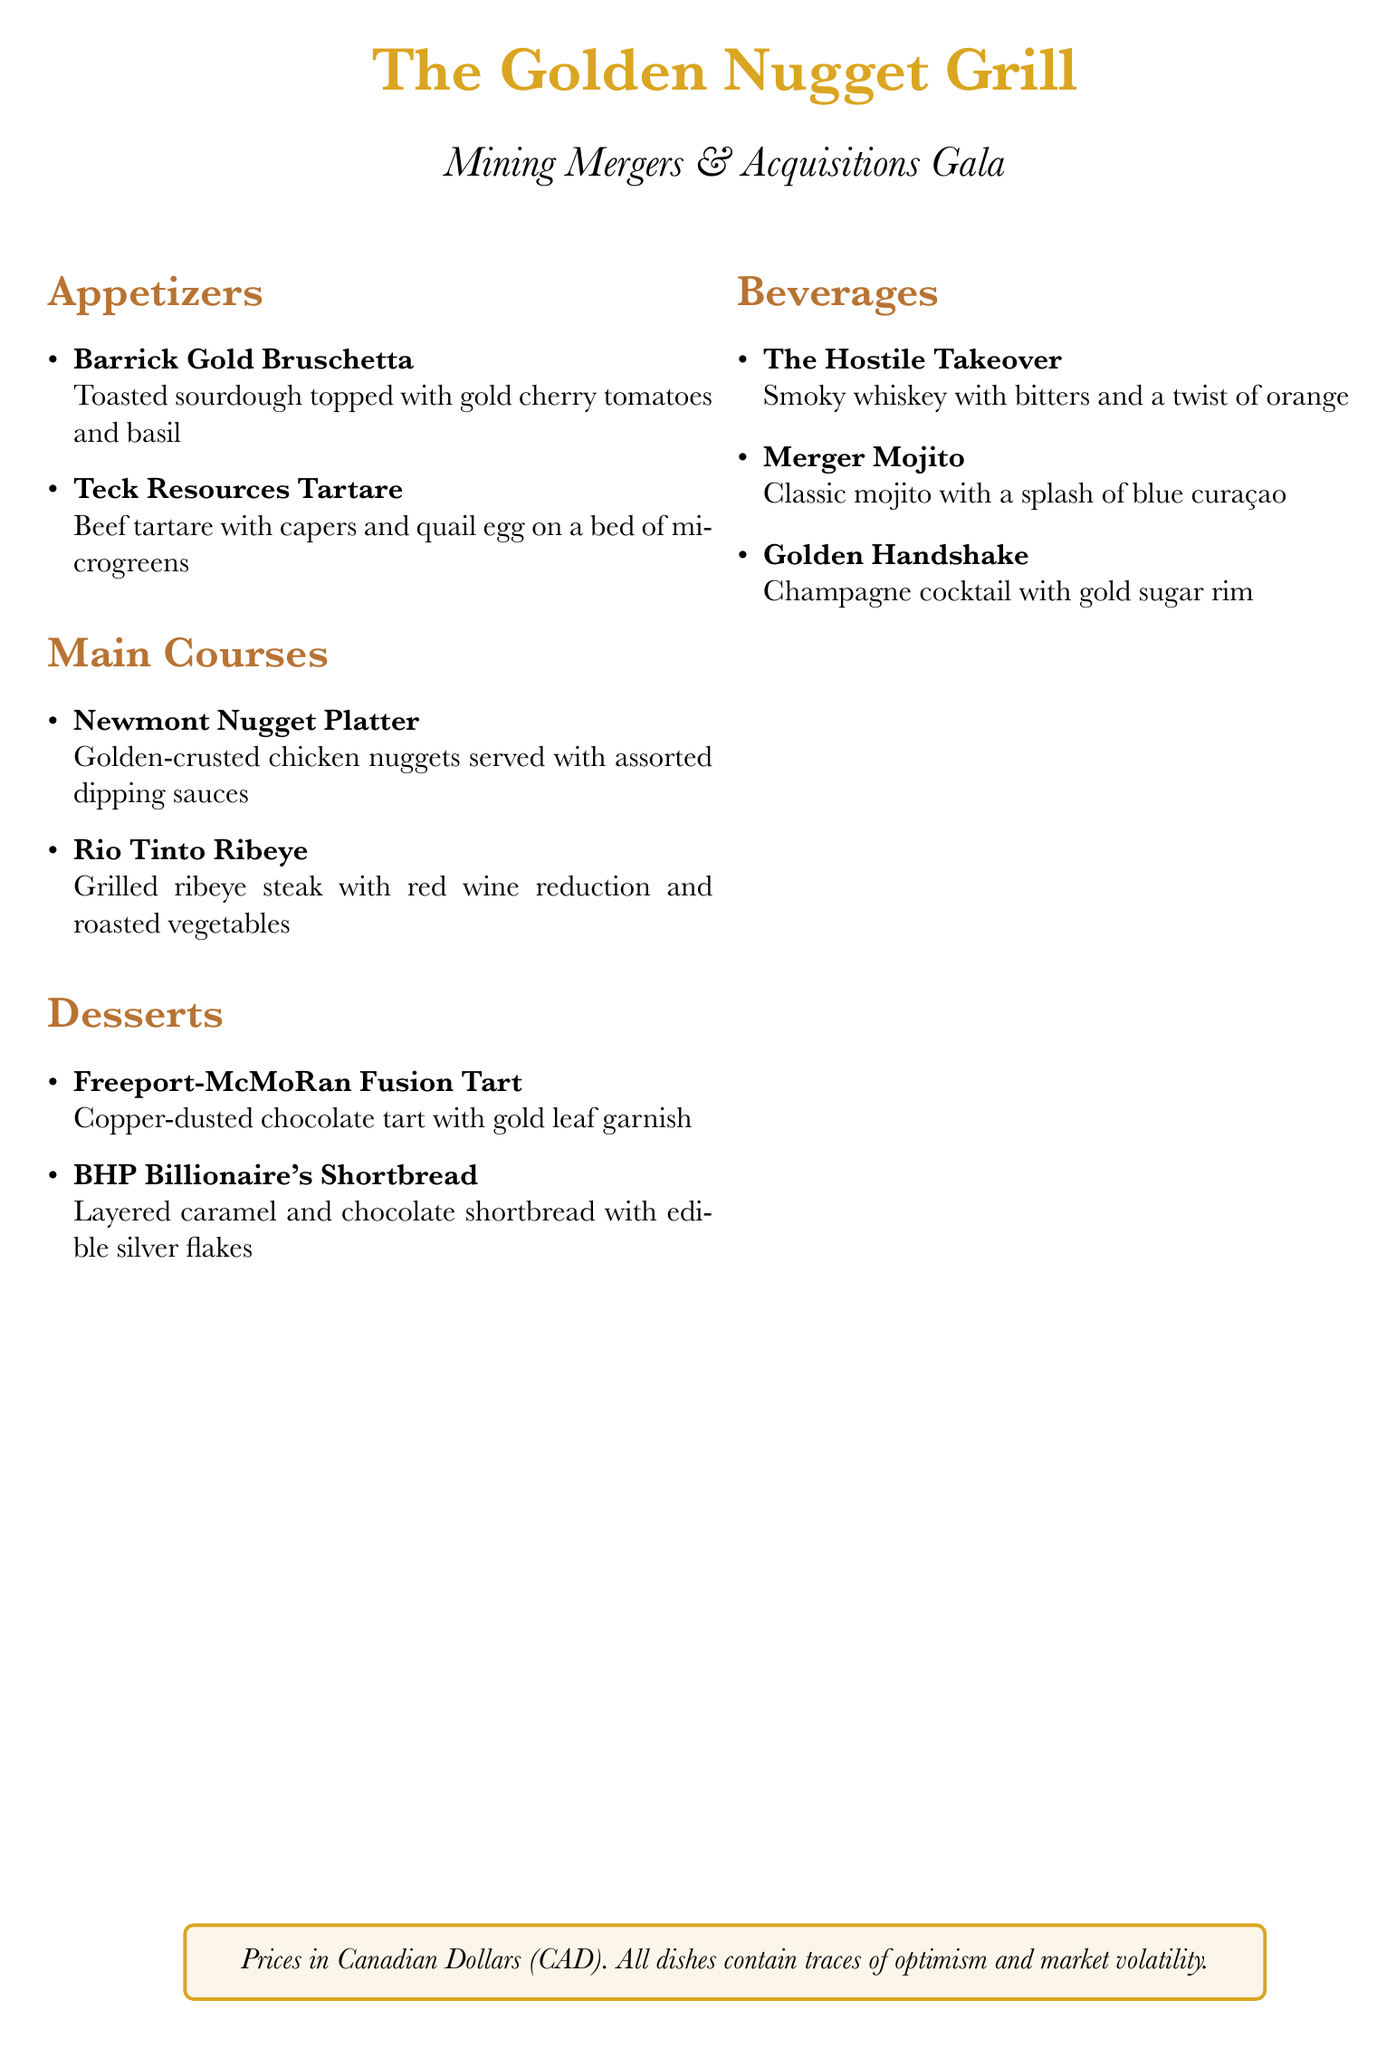What is the name of the restaurant? The name of the restaurant is provided at the top of the menu.
Answer: The Golden Nugget Grill What appetizer features quail egg? The menu has one appetizer that includes quail egg as an ingredient.
Answer: Teck Resources Tartare Which cocktail has a gold sugar rim? The cocktail with a gold sugar rim is specifically named in the beverage section.
Answer: Golden Handshake How many main courses are listed? The document shows a section that lists the main courses, and I can count them.
Answer: 2 What dessert includes copper dust? The dessert with copper-dusted chocolate is mentioned in the dessert section.
Answer: Freeport-McMoRan Fusion Tart What is the main ingredient of the Newmont Nugget Platter? The main ingredient of the Newmont Nugget Platter is specified on the menu.
Answer: Chicken nuggets What color is the theme for the document? The document has a specific color used for headings, which can be found in several sections.
Answer: Copper What type of event is this menu for? The type of event the menu is designed for is indicated in the title.
Answer: Mining Mergers & Acquisitions Gala 